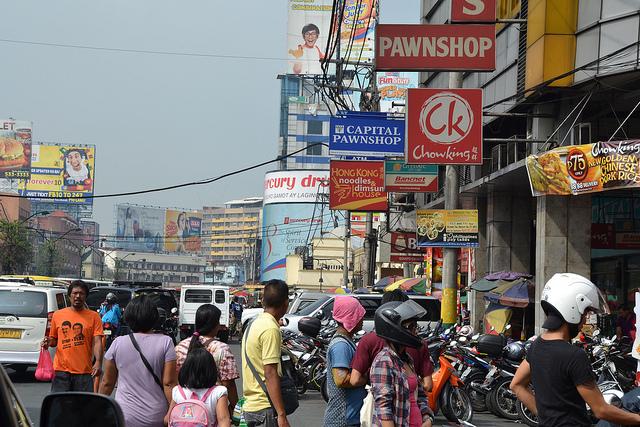Are there people wearing helmets?
Give a very brief answer. Yes. What is the lady pushing?
Write a very short answer. Nothing. What color is the umbrella?
Short answer required. Blue. How many pawn shop signs can be seen?
Keep it brief. 2. 